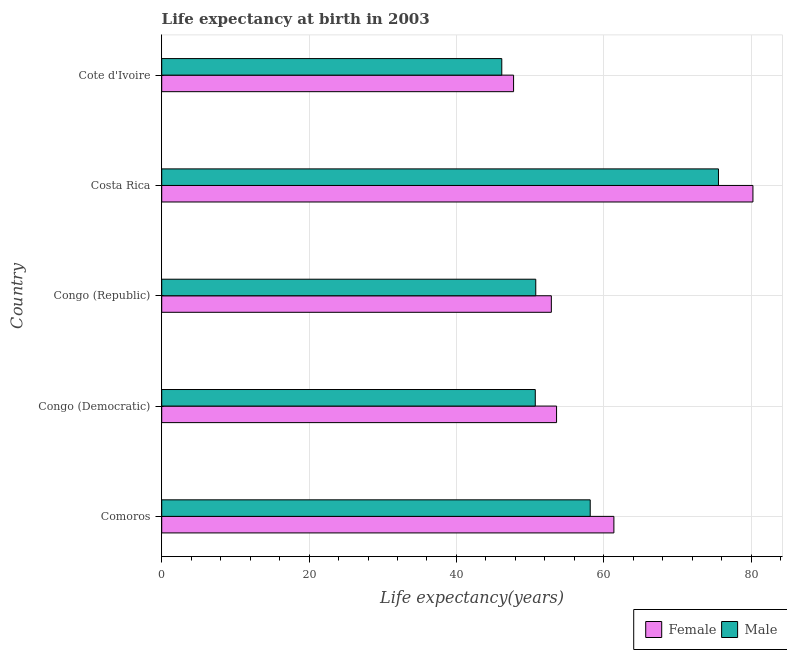How many different coloured bars are there?
Keep it short and to the point. 2. How many groups of bars are there?
Keep it short and to the point. 5. Are the number of bars per tick equal to the number of legend labels?
Your answer should be very brief. Yes. Are the number of bars on each tick of the Y-axis equal?
Provide a succinct answer. Yes. How many bars are there on the 4th tick from the top?
Keep it short and to the point. 2. How many bars are there on the 4th tick from the bottom?
Provide a succinct answer. 2. What is the label of the 4th group of bars from the top?
Provide a short and direct response. Congo (Democratic). In how many cases, is the number of bars for a given country not equal to the number of legend labels?
Offer a very short reply. 0. What is the life expectancy(male) in Congo (Democratic)?
Make the answer very short. 50.7. Across all countries, what is the maximum life expectancy(male)?
Offer a terse response. 75.56. Across all countries, what is the minimum life expectancy(male)?
Make the answer very short. 46.15. In which country was the life expectancy(female) maximum?
Provide a short and direct response. Costa Rica. In which country was the life expectancy(female) minimum?
Offer a very short reply. Cote d'Ivoire. What is the total life expectancy(male) in the graph?
Offer a terse response. 281.32. What is the difference between the life expectancy(female) in Comoros and that in Costa Rica?
Your response must be concise. -18.87. What is the difference between the life expectancy(female) in Congo (Democratic) and the life expectancy(male) in Comoros?
Keep it short and to the point. -4.57. What is the average life expectancy(male) per country?
Offer a very short reply. 56.27. What is the difference between the life expectancy(male) and life expectancy(female) in Congo (Republic)?
Provide a succinct answer. -2.11. In how many countries, is the life expectancy(male) greater than 40 years?
Provide a short and direct response. 5. What is the ratio of the life expectancy(male) in Comoros to that in Costa Rica?
Make the answer very short. 0.77. What is the difference between the highest and the second highest life expectancy(female)?
Offer a terse response. 18.87. What is the difference between the highest and the lowest life expectancy(female)?
Provide a succinct answer. 32.48. In how many countries, is the life expectancy(male) greater than the average life expectancy(male) taken over all countries?
Offer a terse response. 2. Is the sum of the life expectancy(female) in Comoros and Costa Rica greater than the maximum life expectancy(male) across all countries?
Your response must be concise. Yes. What does the 1st bar from the top in Congo (Democratic) represents?
Offer a very short reply. Male. Are all the bars in the graph horizontal?
Ensure brevity in your answer.  Yes. How many countries are there in the graph?
Your answer should be compact. 5. How many legend labels are there?
Give a very brief answer. 2. What is the title of the graph?
Your response must be concise. Life expectancy at birth in 2003. Does "Registered firms" appear as one of the legend labels in the graph?
Give a very brief answer. No. What is the label or title of the X-axis?
Your answer should be compact. Life expectancy(years). What is the Life expectancy(years) of Female in Comoros?
Offer a terse response. 61.37. What is the Life expectancy(years) in Male in Comoros?
Ensure brevity in your answer.  58.15. What is the Life expectancy(years) in Female in Congo (Democratic)?
Ensure brevity in your answer.  53.59. What is the Life expectancy(years) in Male in Congo (Democratic)?
Your answer should be very brief. 50.7. What is the Life expectancy(years) in Female in Congo (Republic)?
Ensure brevity in your answer.  52.88. What is the Life expectancy(years) of Male in Congo (Republic)?
Keep it short and to the point. 50.76. What is the Life expectancy(years) in Female in Costa Rica?
Offer a very short reply. 80.24. What is the Life expectancy(years) of Male in Costa Rica?
Provide a short and direct response. 75.56. What is the Life expectancy(years) in Female in Cote d'Ivoire?
Provide a short and direct response. 47.75. What is the Life expectancy(years) of Male in Cote d'Ivoire?
Provide a short and direct response. 46.15. Across all countries, what is the maximum Life expectancy(years) of Female?
Ensure brevity in your answer.  80.24. Across all countries, what is the maximum Life expectancy(years) in Male?
Ensure brevity in your answer.  75.56. Across all countries, what is the minimum Life expectancy(years) in Female?
Keep it short and to the point. 47.75. Across all countries, what is the minimum Life expectancy(years) in Male?
Provide a succinct answer. 46.15. What is the total Life expectancy(years) in Female in the graph?
Your response must be concise. 295.82. What is the total Life expectancy(years) in Male in the graph?
Give a very brief answer. 281.32. What is the difference between the Life expectancy(years) in Female in Comoros and that in Congo (Democratic)?
Provide a succinct answer. 7.78. What is the difference between the Life expectancy(years) in Male in Comoros and that in Congo (Democratic)?
Your answer should be very brief. 7.46. What is the difference between the Life expectancy(years) of Female in Comoros and that in Congo (Republic)?
Ensure brevity in your answer.  8.49. What is the difference between the Life expectancy(years) of Male in Comoros and that in Congo (Republic)?
Offer a terse response. 7.39. What is the difference between the Life expectancy(years) in Female in Comoros and that in Costa Rica?
Make the answer very short. -18.87. What is the difference between the Life expectancy(years) of Male in Comoros and that in Costa Rica?
Your answer should be very brief. -17.41. What is the difference between the Life expectancy(years) of Female in Comoros and that in Cote d'Ivoire?
Give a very brief answer. 13.61. What is the difference between the Life expectancy(years) in Male in Comoros and that in Cote d'Ivoire?
Ensure brevity in your answer.  12. What is the difference between the Life expectancy(years) in Female in Congo (Democratic) and that in Congo (Republic)?
Make the answer very short. 0.71. What is the difference between the Life expectancy(years) of Male in Congo (Democratic) and that in Congo (Republic)?
Provide a succinct answer. -0.07. What is the difference between the Life expectancy(years) of Female in Congo (Democratic) and that in Costa Rica?
Your answer should be very brief. -26.65. What is the difference between the Life expectancy(years) of Male in Congo (Democratic) and that in Costa Rica?
Provide a short and direct response. -24.86. What is the difference between the Life expectancy(years) in Female in Congo (Democratic) and that in Cote d'Ivoire?
Your response must be concise. 5.83. What is the difference between the Life expectancy(years) in Male in Congo (Democratic) and that in Cote d'Ivoire?
Ensure brevity in your answer.  4.55. What is the difference between the Life expectancy(years) of Female in Congo (Republic) and that in Costa Rica?
Your answer should be compact. -27.36. What is the difference between the Life expectancy(years) of Male in Congo (Republic) and that in Costa Rica?
Keep it short and to the point. -24.8. What is the difference between the Life expectancy(years) of Female in Congo (Republic) and that in Cote d'Ivoire?
Provide a succinct answer. 5.12. What is the difference between the Life expectancy(years) of Male in Congo (Republic) and that in Cote d'Ivoire?
Provide a succinct answer. 4.61. What is the difference between the Life expectancy(years) of Female in Costa Rica and that in Cote d'Ivoire?
Offer a terse response. 32.48. What is the difference between the Life expectancy(years) of Male in Costa Rica and that in Cote d'Ivoire?
Give a very brief answer. 29.41. What is the difference between the Life expectancy(years) in Female in Comoros and the Life expectancy(years) in Male in Congo (Democratic)?
Give a very brief answer. 10.67. What is the difference between the Life expectancy(years) of Female in Comoros and the Life expectancy(years) of Male in Congo (Republic)?
Offer a terse response. 10.6. What is the difference between the Life expectancy(years) in Female in Comoros and the Life expectancy(years) in Male in Costa Rica?
Provide a short and direct response. -14.19. What is the difference between the Life expectancy(years) of Female in Comoros and the Life expectancy(years) of Male in Cote d'Ivoire?
Your answer should be compact. 15.21. What is the difference between the Life expectancy(years) in Female in Congo (Democratic) and the Life expectancy(years) in Male in Congo (Republic)?
Keep it short and to the point. 2.82. What is the difference between the Life expectancy(years) in Female in Congo (Democratic) and the Life expectancy(years) in Male in Costa Rica?
Provide a succinct answer. -21.97. What is the difference between the Life expectancy(years) in Female in Congo (Democratic) and the Life expectancy(years) in Male in Cote d'Ivoire?
Give a very brief answer. 7.43. What is the difference between the Life expectancy(years) in Female in Congo (Republic) and the Life expectancy(years) in Male in Costa Rica?
Ensure brevity in your answer.  -22.68. What is the difference between the Life expectancy(years) of Female in Congo (Republic) and the Life expectancy(years) of Male in Cote d'Ivoire?
Keep it short and to the point. 6.72. What is the difference between the Life expectancy(years) in Female in Costa Rica and the Life expectancy(years) in Male in Cote d'Ivoire?
Keep it short and to the point. 34.08. What is the average Life expectancy(years) of Female per country?
Ensure brevity in your answer.  59.16. What is the average Life expectancy(years) of Male per country?
Keep it short and to the point. 56.27. What is the difference between the Life expectancy(years) of Female and Life expectancy(years) of Male in Comoros?
Give a very brief answer. 3.21. What is the difference between the Life expectancy(years) in Female and Life expectancy(years) in Male in Congo (Democratic)?
Your response must be concise. 2.89. What is the difference between the Life expectancy(years) of Female and Life expectancy(years) of Male in Congo (Republic)?
Your response must be concise. 2.11. What is the difference between the Life expectancy(years) in Female and Life expectancy(years) in Male in Costa Rica?
Your answer should be very brief. 4.68. What is the difference between the Life expectancy(years) in Female and Life expectancy(years) in Male in Cote d'Ivoire?
Provide a succinct answer. 1.6. What is the ratio of the Life expectancy(years) of Female in Comoros to that in Congo (Democratic)?
Make the answer very short. 1.15. What is the ratio of the Life expectancy(years) of Male in Comoros to that in Congo (Democratic)?
Offer a terse response. 1.15. What is the ratio of the Life expectancy(years) of Female in Comoros to that in Congo (Republic)?
Offer a terse response. 1.16. What is the ratio of the Life expectancy(years) in Male in Comoros to that in Congo (Republic)?
Offer a very short reply. 1.15. What is the ratio of the Life expectancy(years) in Female in Comoros to that in Costa Rica?
Your answer should be very brief. 0.76. What is the ratio of the Life expectancy(years) of Male in Comoros to that in Costa Rica?
Ensure brevity in your answer.  0.77. What is the ratio of the Life expectancy(years) of Female in Comoros to that in Cote d'Ivoire?
Your answer should be compact. 1.29. What is the ratio of the Life expectancy(years) in Male in Comoros to that in Cote d'Ivoire?
Your response must be concise. 1.26. What is the ratio of the Life expectancy(years) in Female in Congo (Democratic) to that in Congo (Republic)?
Your answer should be compact. 1.01. What is the ratio of the Life expectancy(years) in Female in Congo (Democratic) to that in Costa Rica?
Your answer should be very brief. 0.67. What is the ratio of the Life expectancy(years) in Male in Congo (Democratic) to that in Costa Rica?
Your answer should be compact. 0.67. What is the ratio of the Life expectancy(years) in Female in Congo (Democratic) to that in Cote d'Ivoire?
Ensure brevity in your answer.  1.12. What is the ratio of the Life expectancy(years) in Male in Congo (Democratic) to that in Cote d'Ivoire?
Provide a short and direct response. 1.1. What is the ratio of the Life expectancy(years) of Female in Congo (Republic) to that in Costa Rica?
Offer a very short reply. 0.66. What is the ratio of the Life expectancy(years) in Male in Congo (Republic) to that in Costa Rica?
Keep it short and to the point. 0.67. What is the ratio of the Life expectancy(years) of Female in Congo (Republic) to that in Cote d'Ivoire?
Your response must be concise. 1.11. What is the ratio of the Life expectancy(years) in Male in Congo (Republic) to that in Cote d'Ivoire?
Ensure brevity in your answer.  1.1. What is the ratio of the Life expectancy(years) of Female in Costa Rica to that in Cote d'Ivoire?
Your response must be concise. 1.68. What is the ratio of the Life expectancy(years) in Male in Costa Rica to that in Cote d'Ivoire?
Provide a succinct answer. 1.64. What is the difference between the highest and the second highest Life expectancy(years) in Female?
Offer a terse response. 18.87. What is the difference between the highest and the second highest Life expectancy(years) of Male?
Provide a succinct answer. 17.41. What is the difference between the highest and the lowest Life expectancy(years) in Female?
Provide a succinct answer. 32.48. What is the difference between the highest and the lowest Life expectancy(years) of Male?
Your response must be concise. 29.41. 